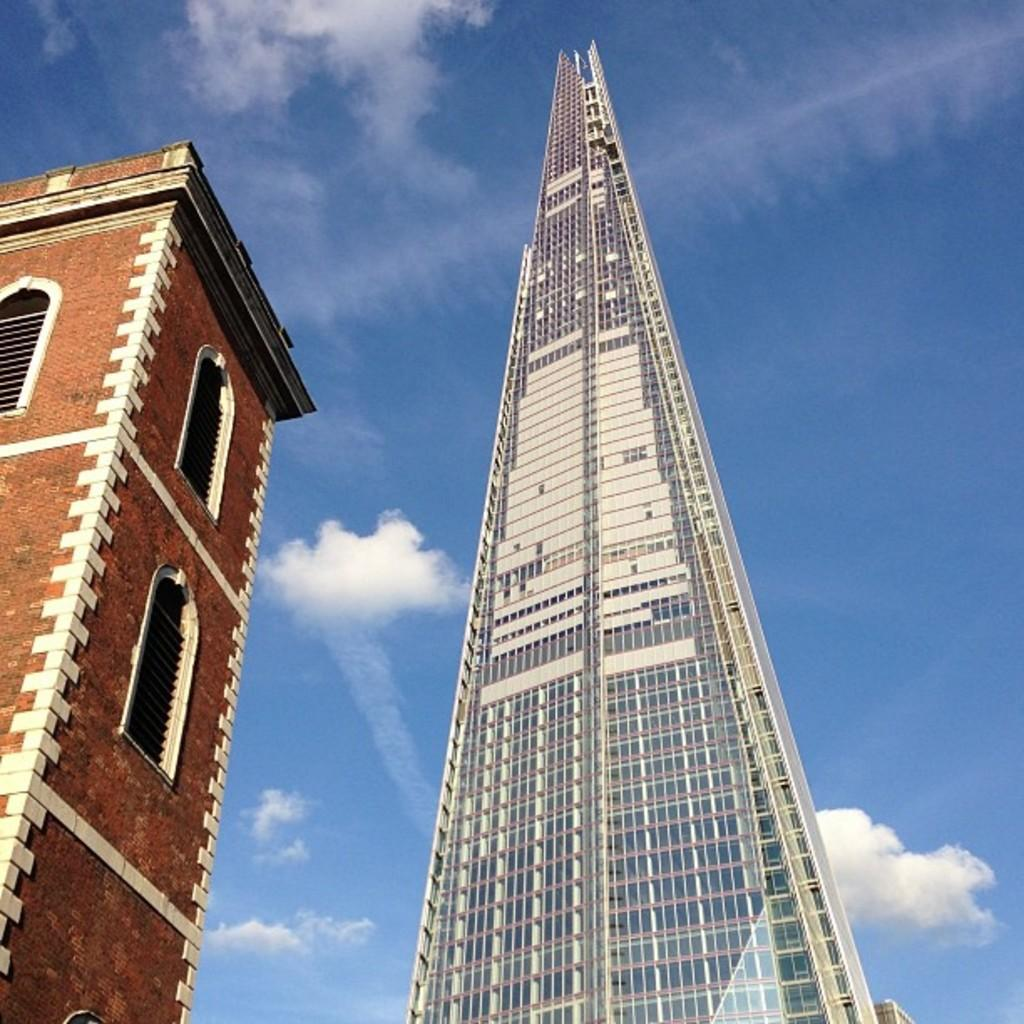What type of structures are present in the image? There are two tower buildings in the image. What can be seen in the background of the image? The sky is visible in the background of the image. What type of list can be seen hanging from the window in the image? There is no window or list present in the image; it only features two tower buildings and the sky in the background. 